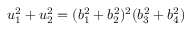Convert formula to latex. <formula><loc_0><loc_0><loc_500><loc_500>u _ { 1 } ^ { 2 } + u _ { 2 } ^ { 2 } = ( b _ { 1 } ^ { 2 } + b _ { 2 } ^ { 2 } ) ^ { 2 } ( b _ { 3 } ^ { 2 } + b _ { 4 } ^ { 2 } )</formula> 